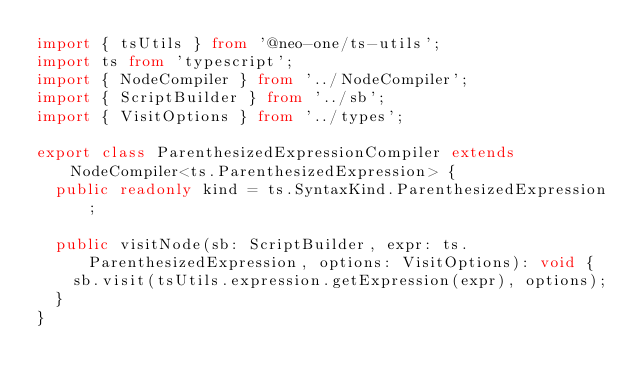<code> <loc_0><loc_0><loc_500><loc_500><_TypeScript_>import { tsUtils } from '@neo-one/ts-utils';
import ts from 'typescript';
import { NodeCompiler } from '../NodeCompiler';
import { ScriptBuilder } from '../sb';
import { VisitOptions } from '../types';

export class ParenthesizedExpressionCompiler extends NodeCompiler<ts.ParenthesizedExpression> {
  public readonly kind = ts.SyntaxKind.ParenthesizedExpression;

  public visitNode(sb: ScriptBuilder, expr: ts.ParenthesizedExpression, options: VisitOptions): void {
    sb.visit(tsUtils.expression.getExpression(expr), options);
  }
}
</code> 